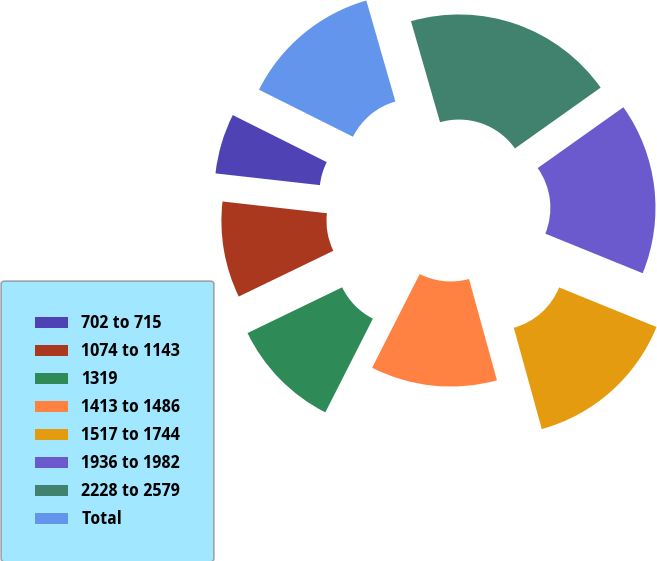<chart> <loc_0><loc_0><loc_500><loc_500><pie_chart><fcel>702 to 715<fcel>1074 to 1143<fcel>1319<fcel>1413 to 1486<fcel>1517 to 1744<fcel>1936 to 1982<fcel>2228 to 2579<fcel>Total<nl><fcel>5.6%<fcel>8.95%<fcel>10.36%<fcel>11.76%<fcel>14.57%<fcel>15.97%<fcel>19.63%<fcel>13.16%<nl></chart> 